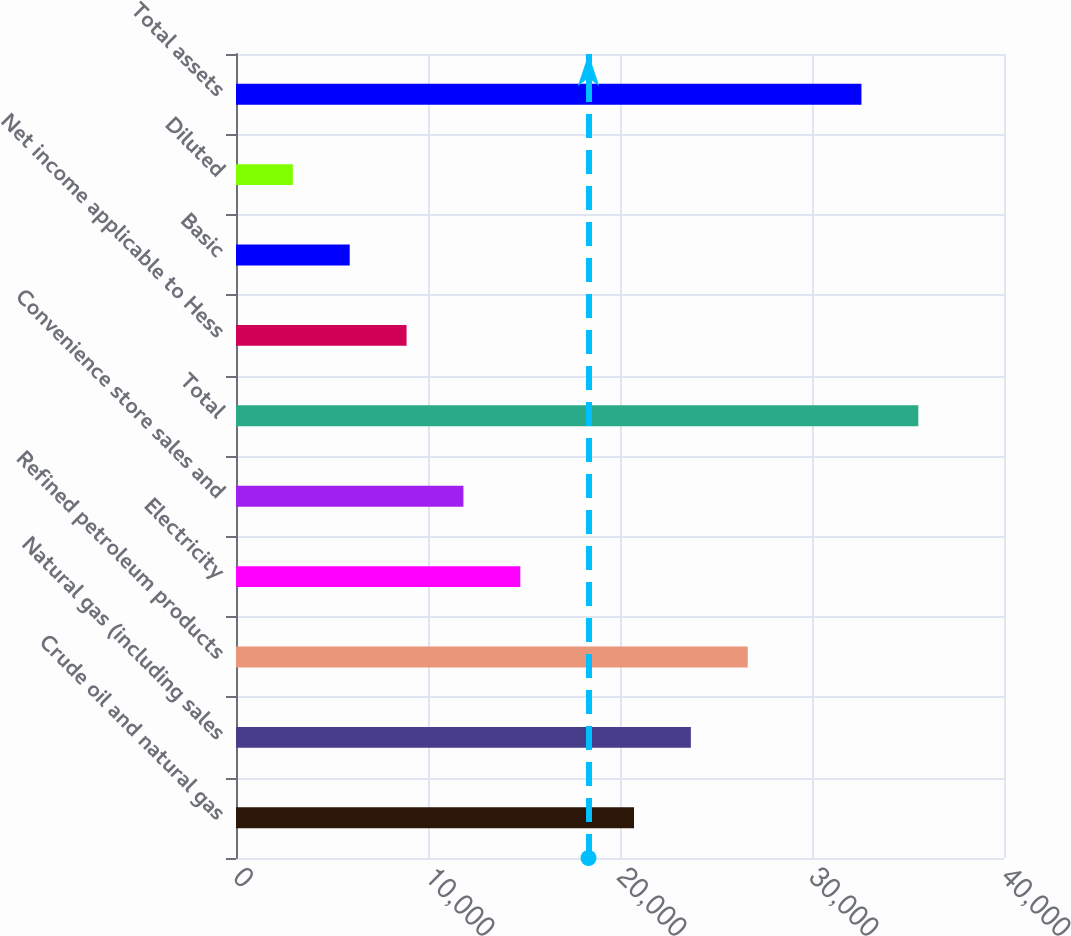<chart> <loc_0><loc_0><loc_500><loc_500><bar_chart><fcel>Crude oil and natural gas<fcel>Natural gas (including sales<fcel>Refined petroleum products<fcel>Electricity<fcel>Convenience store sales and<fcel>Total<fcel>Net income applicable to Hess<fcel>Basic<fcel>Diluted<fcel>Total assets<nl><fcel>20729.9<fcel>23691.3<fcel>26652.6<fcel>14807.2<fcel>11845.8<fcel>35536.7<fcel>8884.48<fcel>5923.12<fcel>2961.76<fcel>32575.4<nl></chart> 